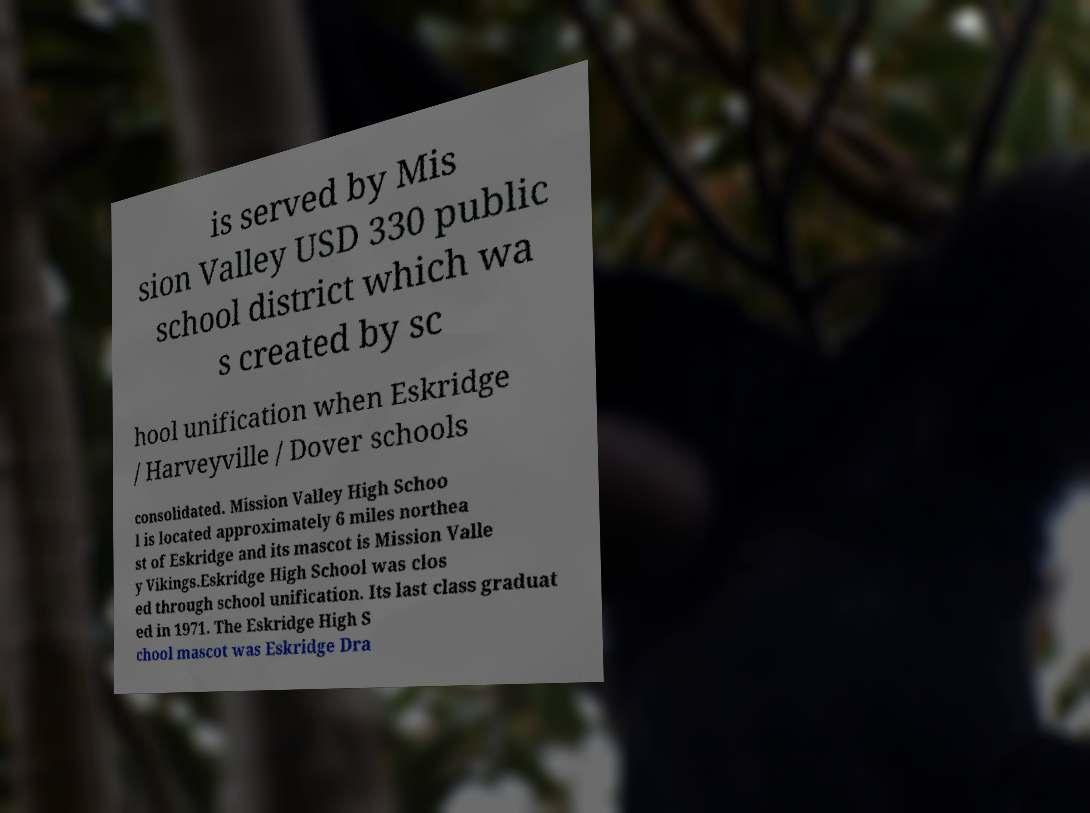What messages or text are displayed in this image? I need them in a readable, typed format. is served by Mis sion Valley USD 330 public school district which wa s created by sc hool unification when Eskridge / Harveyville / Dover schools consolidated. Mission Valley High Schoo l is located approximately 6 miles northea st of Eskridge and its mascot is Mission Valle y Vikings.Eskridge High School was clos ed through school unification. Its last class graduat ed in 1971. The Eskridge High S chool mascot was Eskridge Dra 